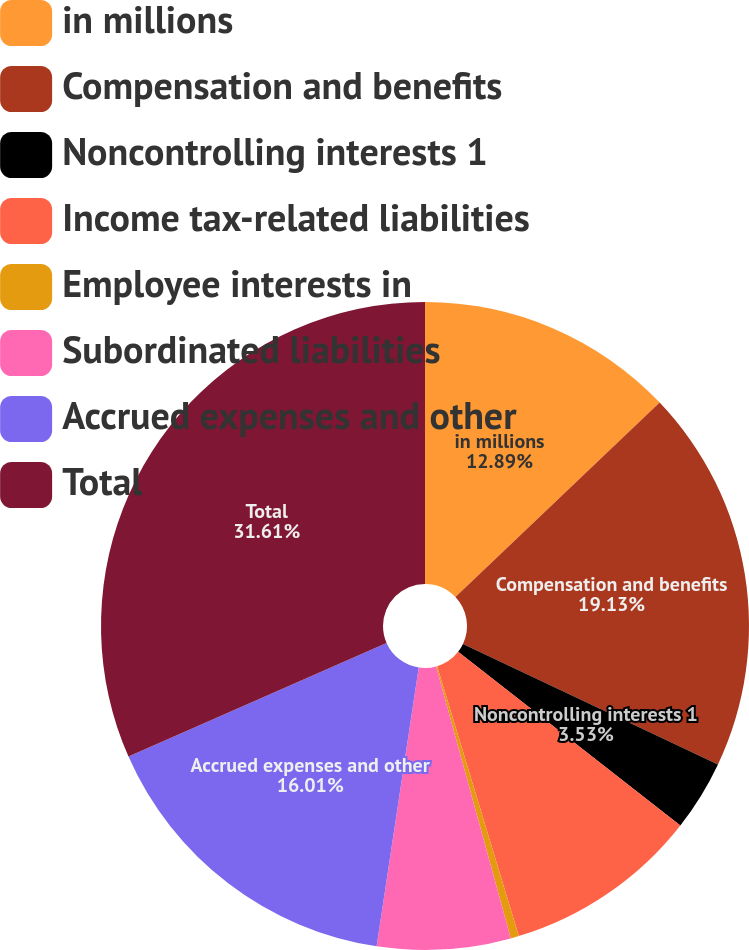Convert chart to OTSL. <chart><loc_0><loc_0><loc_500><loc_500><pie_chart><fcel>in millions<fcel>Compensation and benefits<fcel>Noncontrolling interests 1<fcel>Income tax-related liabilities<fcel>Employee interests in<fcel>Subordinated liabilities<fcel>Accrued expenses and other<fcel>Total<nl><fcel>12.89%<fcel>19.13%<fcel>3.53%<fcel>9.77%<fcel>0.41%<fcel>6.65%<fcel>16.01%<fcel>31.6%<nl></chart> 